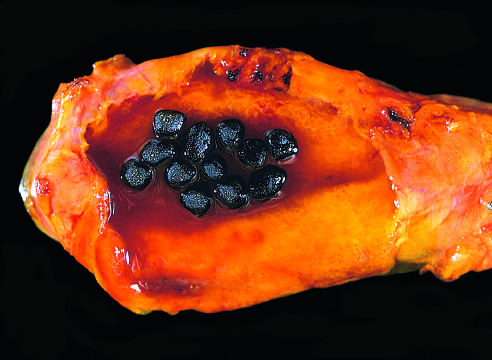how are several faceted black gallstones present?
Answer the question using a single word or phrase. With a mechanical mitral valve prosthesis 